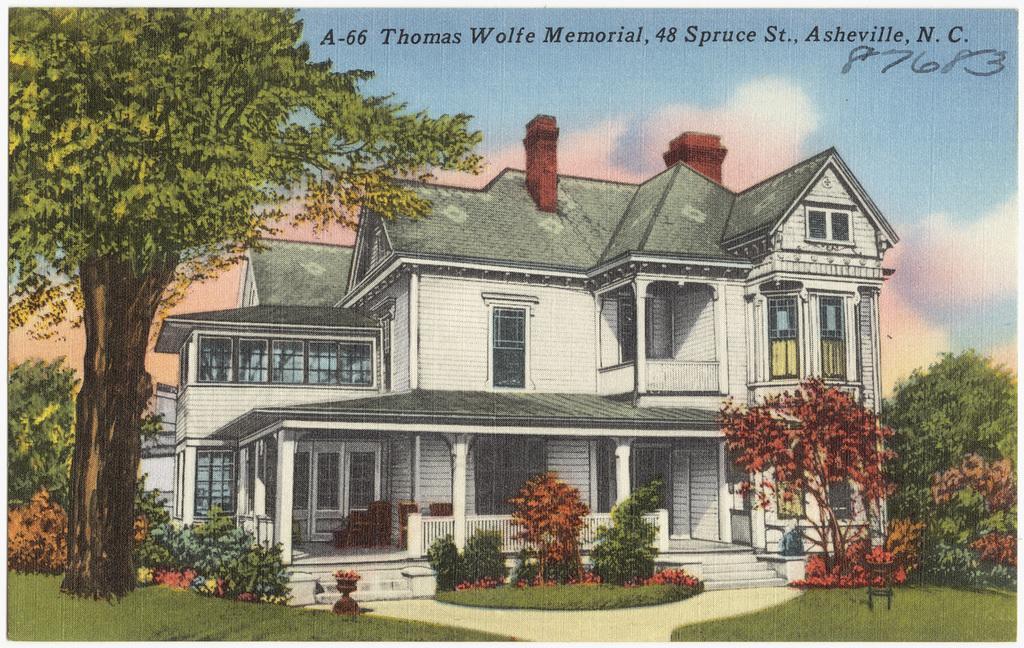Please provide a concise description of this image. This image consists of a painting. Here I can see a building. In front of this building there are many plants. At the bottom, I can see the grass. On the left side there is a tree. At the top, I can see the sky. At the top of this image I can see some text. 